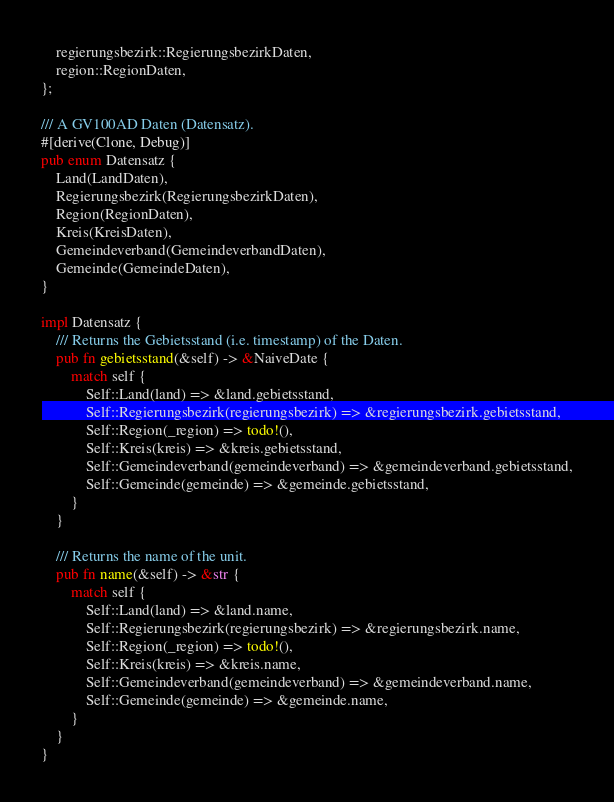Convert code to text. <code><loc_0><loc_0><loc_500><loc_500><_Rust_>    regierungsbezirk::RegierungsbezirkDaten,
    region::RegionDaten,
};

/// A GV100AD Daten (Datensatz).
#[derive(Clone, Debug)]
pub enum Datensatz {
    Land(LandDaten),
    Regierungsbezirk(RegierungsbezirkDaten),
    Region(RegionDaten),
    Kreis(KreisDaten),
    Gemeindeverband(GemeindeverbandDaten),
    Gemeinde(GemeindeDaten),
}

impl Datensatz {
    /// Returns the Gebietsstand (i.e. timestamp) of the Daten.
    pub fn gebietsstand(&self) -> &NaiveDate {
        match self {
            Self::Land(land) => &land.gebietsstand,
            Self::Regierungsbezirk(regierungsbezirk) => &regierungsbezirk.gebietsstand,
            Self::Region(_region) => todo!(),
            Self::Kreis(kreis) => &kreis.gebietsstand,
            Self::Gemeindeverband(gemeindeverband) => &gemeindeverband.gebietsstand,
            Self::Gemeinde(gemeinde) => &gemeinde.gebietsstand,
        }
    }

    /// Returns the name of the unit.
    pub fn name(&self) -> &str {
        match self {
            Self::Land(land) => &land.name,
            Self::Regierungsbezirk(regierungsbezirk) => &regierungsbezirk.name,
            Self::Region(_region) => todo!(),
            Self::Kreis(kreis) => &kreis.name,
            Self::Gemeindeverband(gemeindeverband) => &gemeindeverband.name,
            Self::Gemeinde(gemeinde) => &gemeinde.name,
        }
    }
}
</code> 